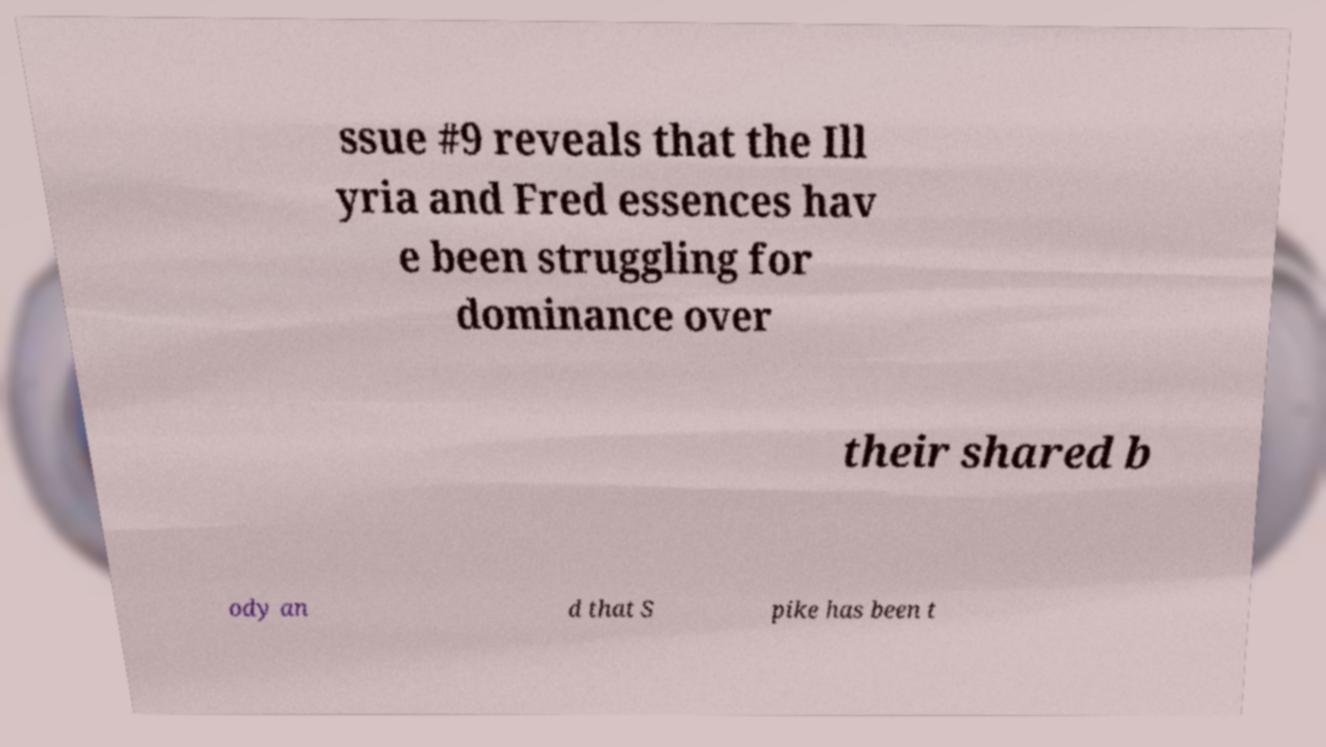Can you read and provide the text displayed in the image?This photo seems to have some interesting text. Can you extract and type it out for me? ssue #9 reveals that the Ill yria and Fred essences hav e been struggling for dominance over their shared b ody an d that S pike has been t 